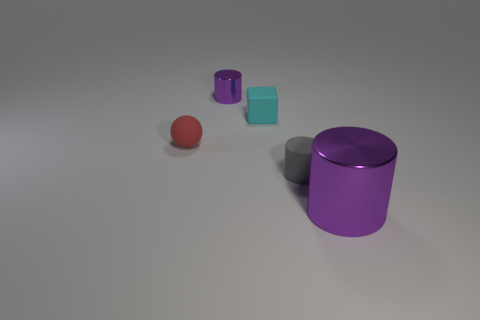What is the color of the metallic cylinder behind the metallic cylinder on the right side of the tiny matte thing in front of the red matte sphere?
Give a very brief answer. Purple. Is the number of objects that are in front of the red rubber ball the same as the number of purple cylinders on the right side of the small purple cylinder?
Provide a succinct answer. No. What is the shape of the red object that is the same size as the cyan thing?
Your answer should be very brief. Sphere. Is there a object that has the same color as the large cylinder?
Your answer should be very brief. Yes. There is a small matte thing behind the small red thing; what is its shape?
Offer a terse response. Cube. The small rubber block has what color?
Give a very brief answer. Cyan. The big thing that is the same material as the tiny purple object is what color?
Your response must be concise. Purple. What number of large cylinders are the same material as the cyan block?
Offer a very short reply. 0. How many blocks are to the right of the big purple shiny object?
Keep it short and to the point. 0. Is the cylinder behind the small matte sphere made of the same material as the object in front of the gray object?
Offer a very short reply. Yes. 